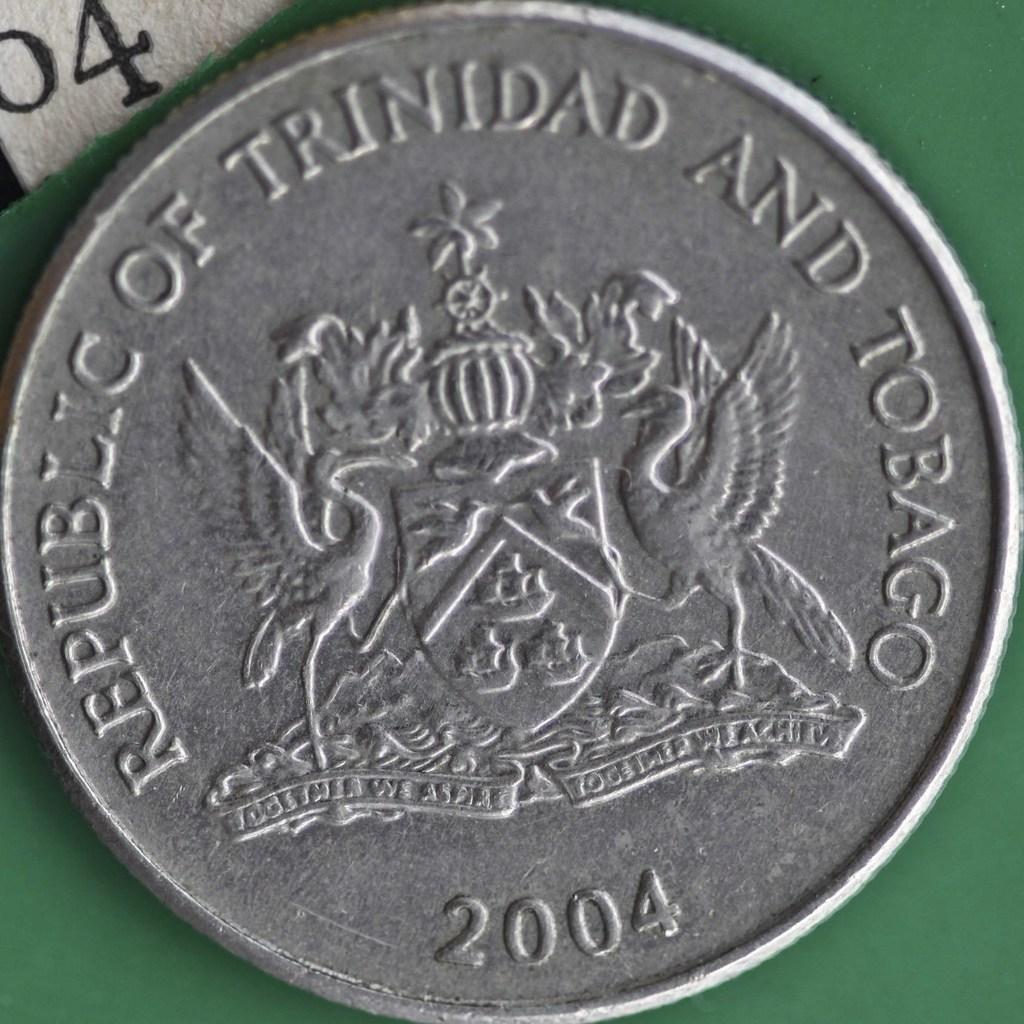<image>
Write a terse but informative summary of the picture. A silver Trinidad and Tobago coin was minted in 2004. 